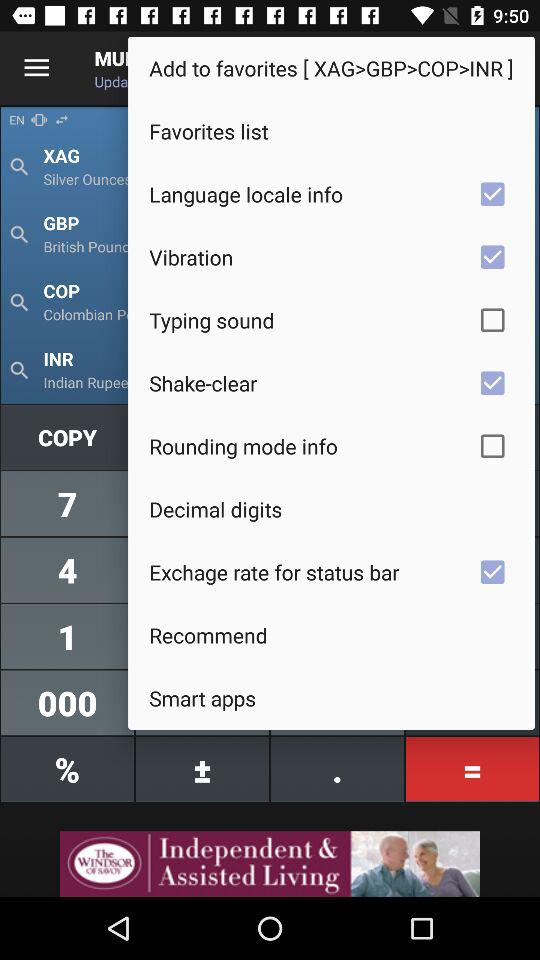What is the status of "Vibration"? The status is "on". 